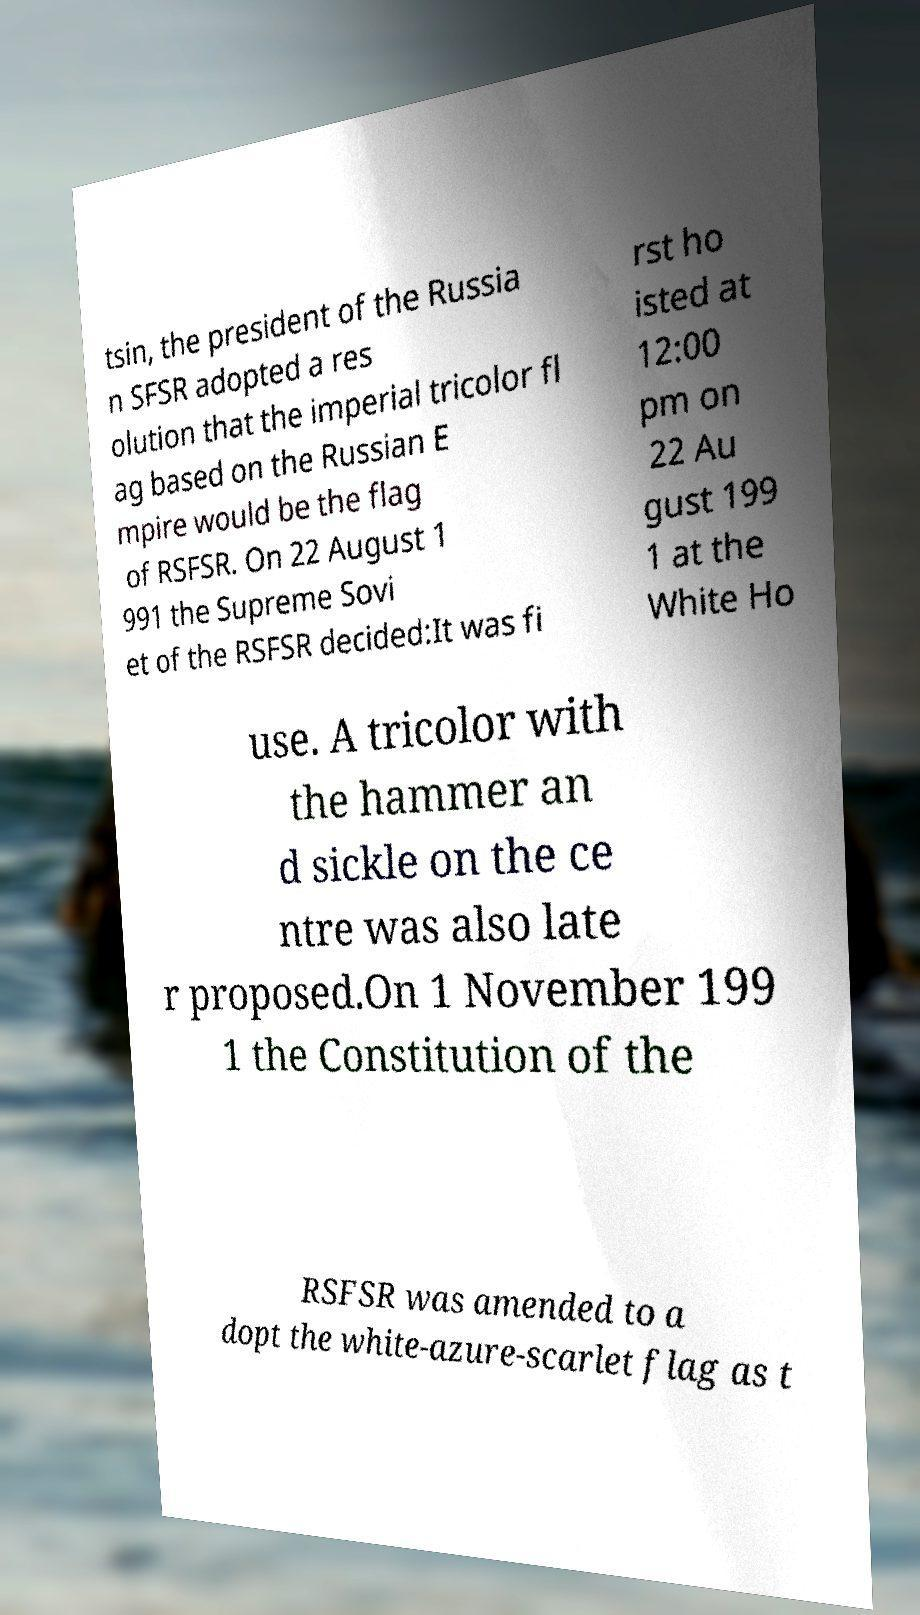There's text embedded in this image that I need extracted. Can you transcribe it verbatim? tsin, the president of the Russia n SFSR adopted a res olution that the imperial tricolor fl ag based on the Russian E mpire would be the flag of RSFSR. On 22 August 1 991 the Supreme Sovi et of the RSFSR decided:It was fi rst ho isted at 12:00 pm on 22 Au gust 199 1 at the White Ho use. A tricolor with the hammer an d sickle on the ce ntre was also late r proposed.On 1 November 199 1 the Constitution of the RSFSR was amended to a dopt the white-azure-scarlet flag as t 